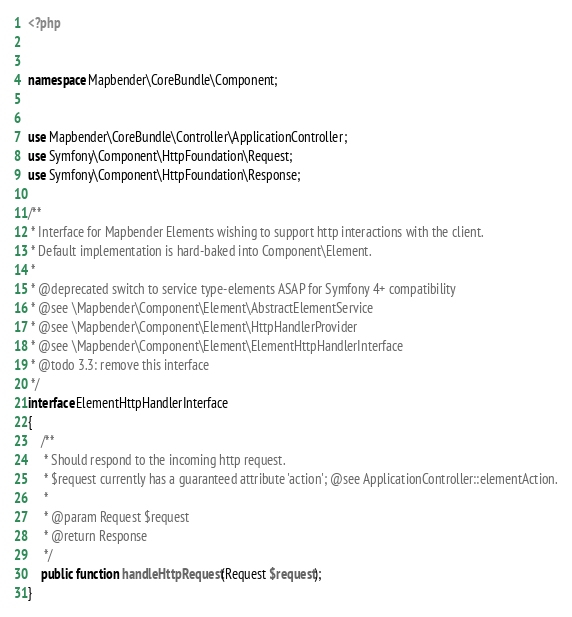Convert code to text. <code><loc_0><loc_0><loc_500><loc_500><_PHP_><?php


namespace Mapbender\CoreBundle\Component;


use Mapbender\CoreBundle\Controller\ApplicationController;
use Symfony\Component\HttpFoundation\Request;
use Symfony\Component\HttpFoundation\Response;

/**
 * Interface for Mapbender Elements wishing to support http interactions with the client.
 * Default implementation is hard-baked into Component\Element.
 *
 * @deprecated switch to service type-elements ASAP for Symfony 4+ compatibility
 * @see \Mapbender\Component\Element\AbstractElementService
 * @see \Mapbender\Component\Element\HttpHandlerProvider
 * @see \Mapbender\Component\Element\ElementHttpHandlerInterface
 * @todo 3.3: remove this interface
 */
interface ElementHttpHandlerInterface
{
    /**
     * Should respond to the incoming http request.
     * $request currently has a guaranteed attribute 'action'; @see ApplicationController::elementAction.
     *
     * @param Request $request
     * @return Response
     */
    public function handleHttpRequest(Request $request);
}
</code> 